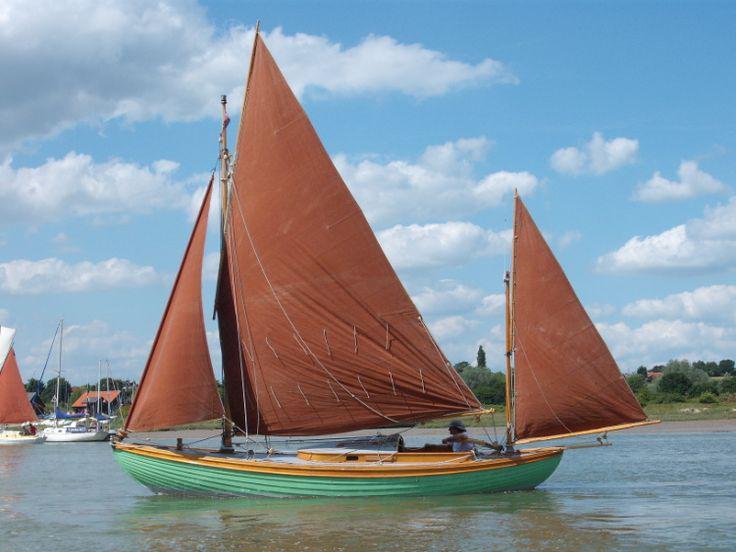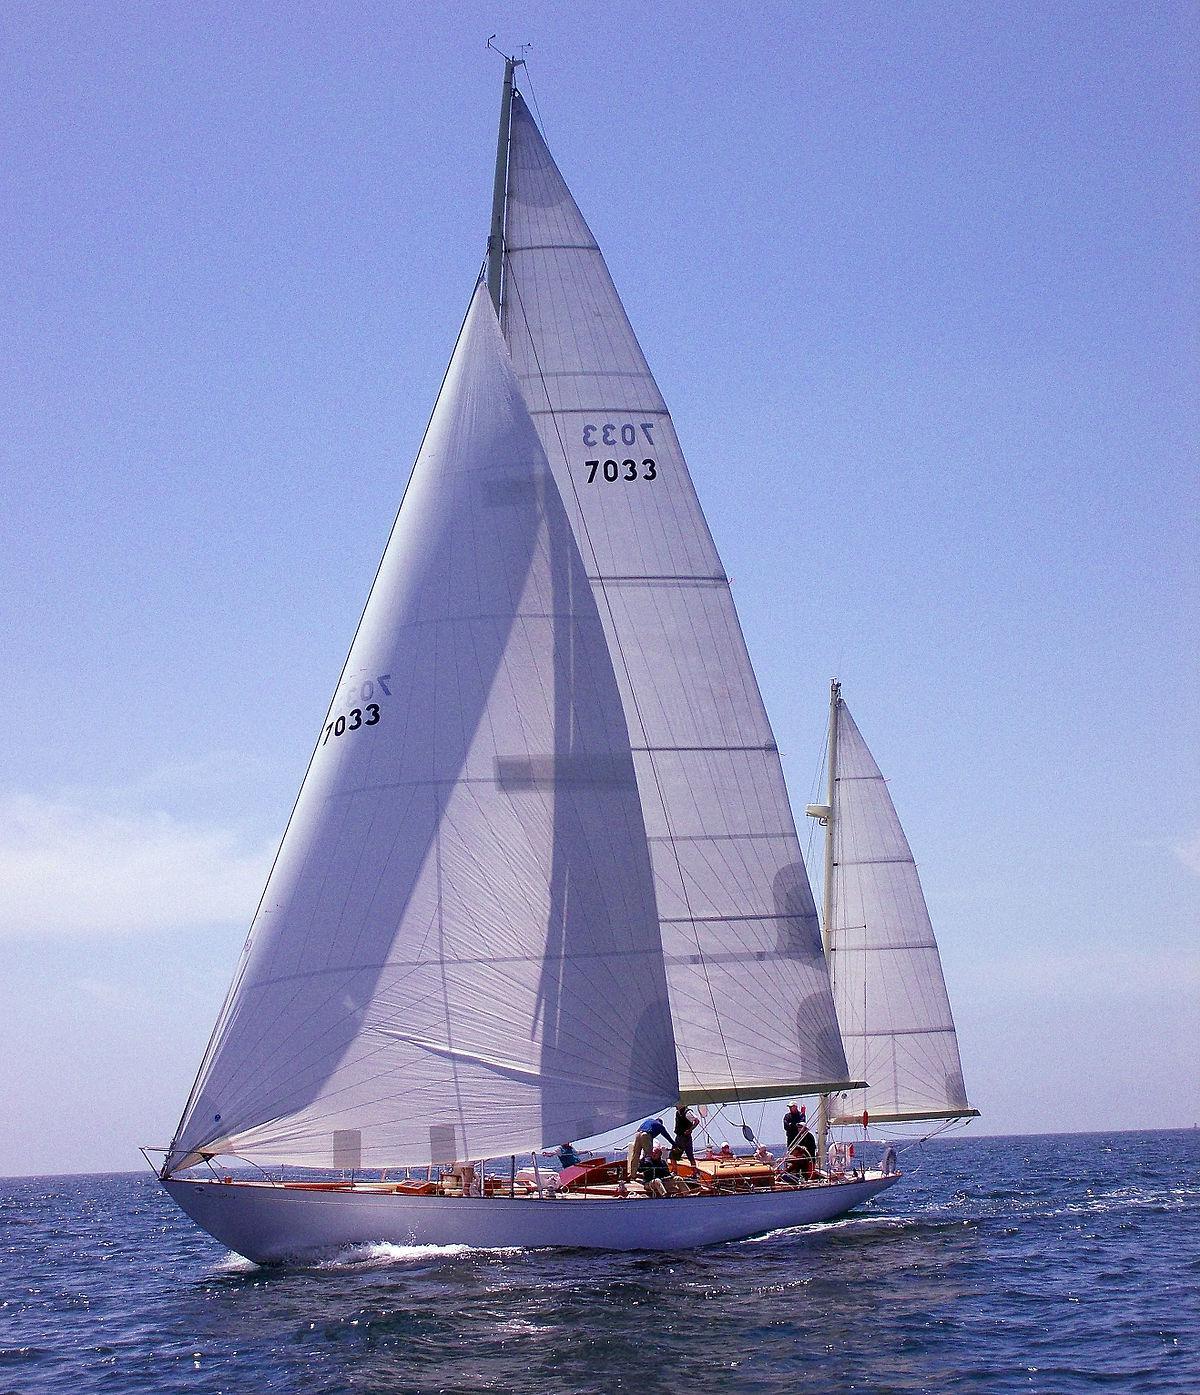The first image is the image on the left, the second image is the image on the right. Considering the images on both sides, is "There’s a single sailboat with at least three brick colored sail deployed to help the boat move." valid? Answer yes or no. Yes. 